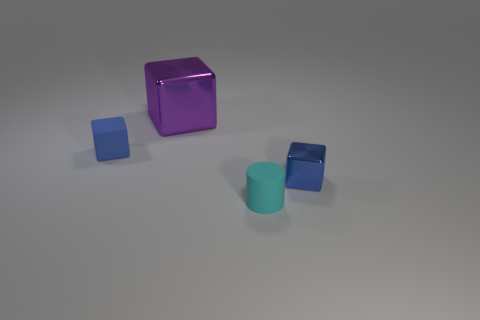What is the shape of the blue matte thing that is the same size as the cyan matte cylinder?
Offer a very short reply. Cube. What number of blocks are both to the left of the matte cylinder and in front of the large cube?
Ensure brevity in your answer.  1. Are there fewer purple cubes that are behind the large purple object than purple cubes?
Make the answer very short. Yes. Are there any cyan rubber cylinders of the same size as the blue rubber block?
Make the answer very short. Yes. There is a tiny block that is the same material as the large object; what color is it?
Offer a terse response. Blue. There is a tiny blue object right of the tiny cyan thing; what number of shiny blocks are behind it?
Your answer should be compact. 1. What material is the tiny thing that is on the left side of the tiny shiny cube and behind the tiny cyan object?
Ensure brevity in your answer.  Rubber. Does the tiny blue object to the left of the tiny shiny block have the same shape as the cyan thing?
Your answer should be very brief. No. Is the number of small metallic objects less than the number of tiny red shiny cylinders?
Offer a very short reply. No. What number of matte objects have the same color as the tiny metallic block?
Offer a terse response. 1. 